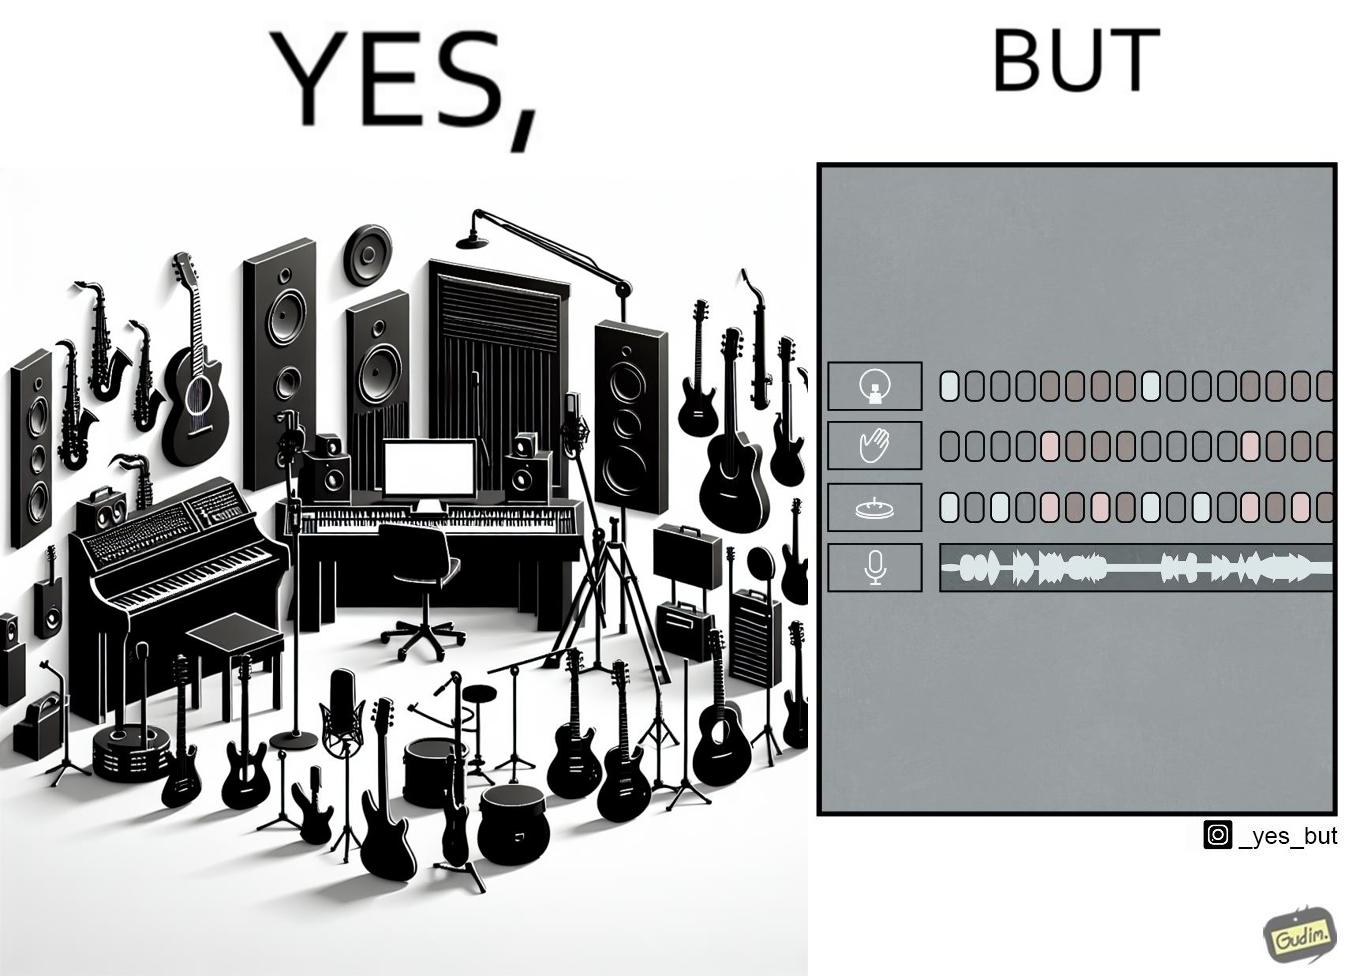What makes this image funny or satirical? The image overall is funny because even though people have great music studios and instruments to create and record music, they use electronic replacements of the musical instruments to achieve the task. 